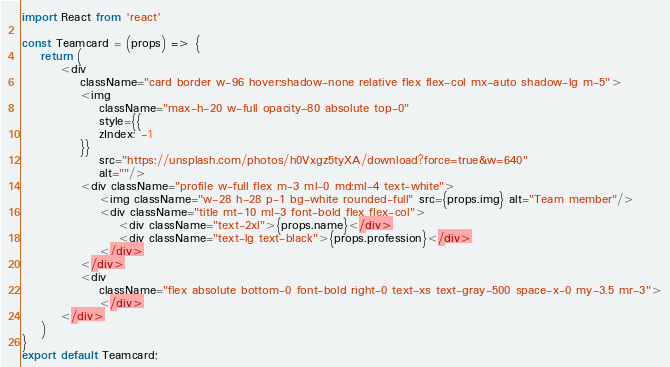Convert code to text. <code><loc_0><loc_0><loc_500><loc_500><_JavaScript_>import React from 'react'

const Teamcard = (props) => {
    return (
        <div
            className="card border w-96 hover:shadow-none relative flex flex-col mx-auto shadow-lg m-5">
            <img
                className="max-h-20 w-full opacity-80 absolute top-0"
                style={{
                zIndex: -1
            }}
                src="https://unsplash.com/photos/h0Vxgz5tyXA/download?force=true&w=640"
                alt=""/>
            <div className="profile w-full flex m-3 ml-0 md:ml-4 text-white">
                <img className="w-28 h-28 p-1 bg-white rounded-full" src={props.img} alt="Team member"/>
                <div className="title mt-10 ml-3 font-bold flex flex-col">
                    <div className="text-2xl">{props.name}</div>
                    <div className="text-lg text-black">{props.profession}</div>
                </div>
            </div>
            <div
                className="flex absolute bottom-0 font-bold right-0 text-xs text-gray-500 space-x-0 my-3.5 mr-3">
                </div>
        </div>
    )
}
export default Teamcard;</code> 